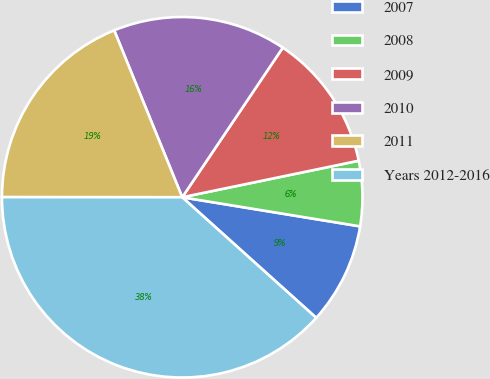Convert chart. <chart><loc_0><loc_0><loc_500><loc_500><pie_chart><fcel>2007<fcel>2008<fcel>2009<fcel>2010<fcel>2011<fcel>Years 2012-2016<nl><fcel>9.08%<fcel>5.83%<fcel>12.33%<fcel>15.58%<fcel>18.83%<fcel>38.35%<nl></chart> 